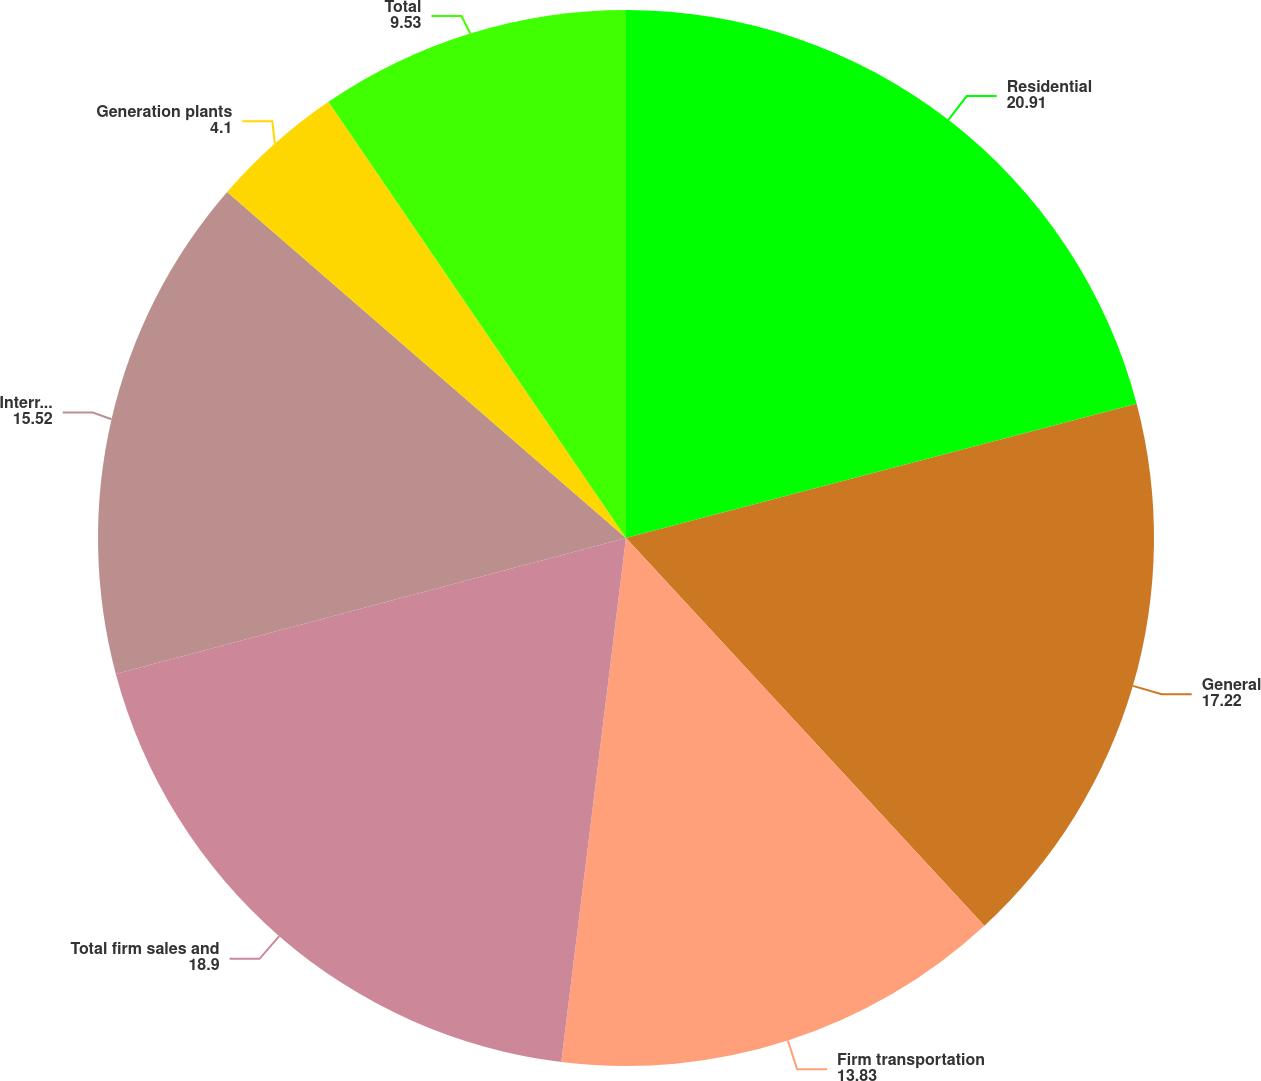<chart> <loc_0><loc_0><loc_500><loc_500><pie_chart><fcel>Residential<fcel>General<fcel>Firm transportation<fcel>Total firm sales and<fcel>Interruptible sales (c)<fcel>Generation plants<fcel>Total<nl><fcel>20.91%<fcel>17.22%<fcel>13.83%<fcel>18.9%<fcel>15.52%<fcel>4.1%<fcel>9.53%<nl></chart> 